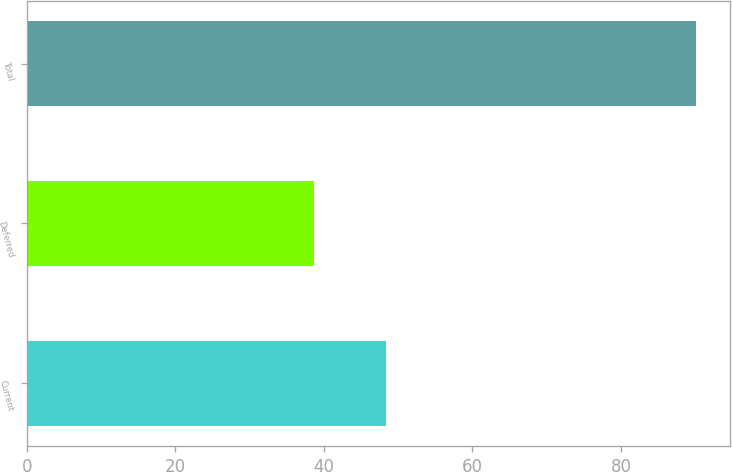Convert chart. <chart><loc_0><loc_0><loc_500><loc_500><bar_chart><fcel>Current<fcel>Deferred<fcel>Total<nl><fcel>48.4<fcel>38.7<fcel>90.1<nl></chart> 